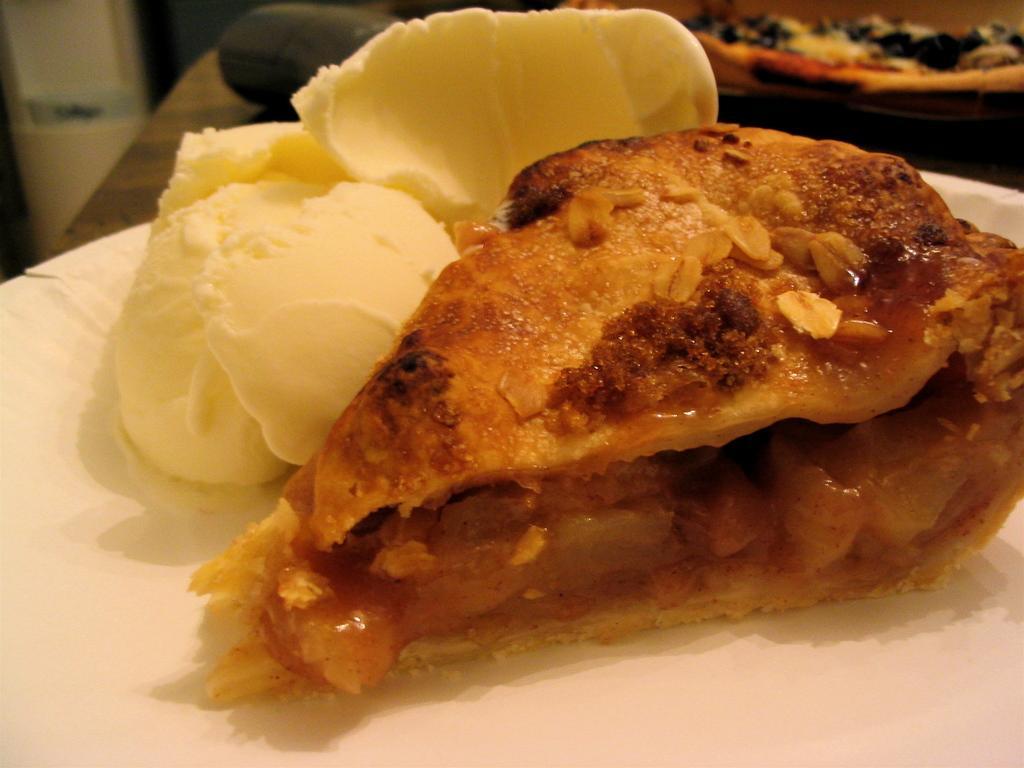Describe this image in one or two sentences. In this image there is some food on the plate which is kept on the table. Right top there is a plate having some food. 